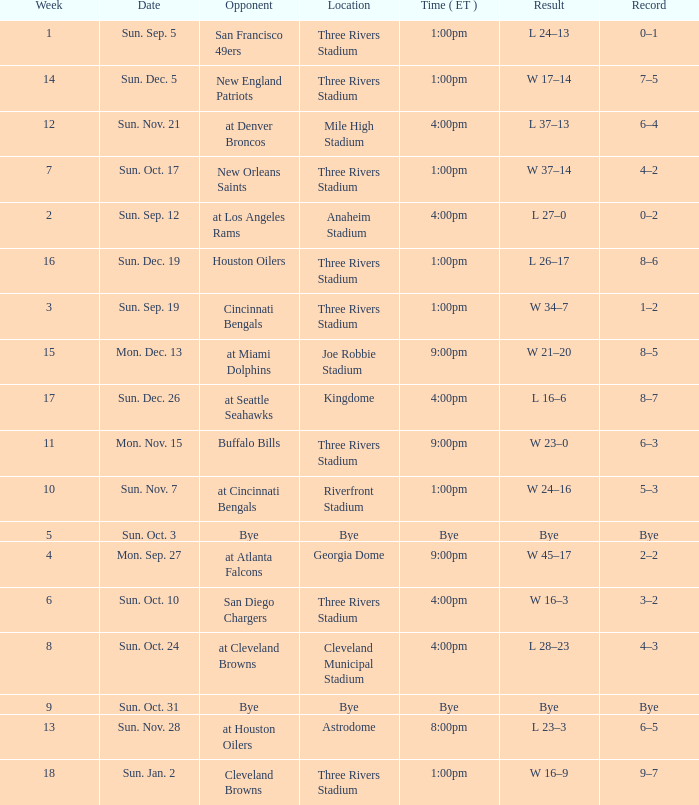What is the result of the game at three rivers stadium with a Record of 6–3? W 23–0. Would you be able to parse every entry in this table? {'header': ['Week', 'Date', 'Opponent', 'Location', 'Time ( ET )', 'Result', 'Record'], 'rows': [['1', 'Sun. Sep. 5', 'San Francisco 49ers', 'Three Rivers Stadium', '1:00pm', 'L 24–13', '0–1'], ['14', 'Sun. Dec. 5', 'New England Patriots', 'Three Rivers Stadium', '1:00pm', 'W 17–14', '7–5'], ['12', 'Sun. Nov. 21', 'at Denver Broncos', 'Mile High Stadium', '4:00pm', 'L 37–13', '6–4'], ['7', 'Sun. Oct. 17', 'New Orleans Saints', 'Three Rivers Stadium', '1:00pm', 'W 37–14', '4–2'], ['2', 'Sun. Sep. 12', 'at Los Angeles Rams', 'Anaheim Stadium', '4:00pm', 'L 27–0', '0–2'], ['16', 'Sun. Dec. 19', 'Houston Oilers', 'Three Rivers Stadium', '1:00pm', 'L 26–17', '8–6'], ['3', 'Sun. Sep. 19', 'Cincinnati Bengals', 'Three Rivers Stadium', '1:00pm', 'W 34–7', '1–2'], ['15', 'Mon. Dec. 13', 'at Miami Dolphins', 'Joe Robbie Stadium', '9:00pm', 'W 21–20', '8–5'], ['17', 'Sun. Dec. 26', 'at Seattle Seahawks', 'Kingdome', '4:00pm', 'L 16–6', '8–7'], ['11', 'Mon. Nov. 15', 'Buffalo Bills', 'Three Rivers Stadium', '9:00pm', 'W 23–0', '6–3'], ['10', 'Sun. Nov. 7', 'at Cincinnati Bengals', 'Riverfront Stadium', '1:00pm', 'W 24–16', '5–3'], ['5', 'Sun. Oct. 3', 'Bye', 'Bye', 'Bye', 'Bye', 'Bye'], ['4', 'Mon. Sep. 27', 'at Atlanta Falcons', 'Georgia Dome', '9:00pm', 'W 45–17', '2–2'], ['6', 'Sun. Oct. 10', 'San Diego Chargers', 'Three Rivers Stadium', '4:00pm', 'W 16–3', '3–2'], ['8', 'Sun. Oct. 24', 'at Cleveland Browns', 'Cleveland Municipal Stadium', '4:00pm', 'L 28–23', '4–3'], ['9', 'Sun. Oct. 31', 'Bye', 'Bye', 'Bye', 'Bye', 'Bye'], ['13', 'Sun. Nov. 28', 'at Houston Oilers', 'Astrodome', '8:00pm', 'L 23–3', '6–5'], ['18', 'Sun. Jan. 2', 'Cleveland Browns', 'Three Rivers Stadium', '1:00pm', 'W 16–9', '9–7']]} 